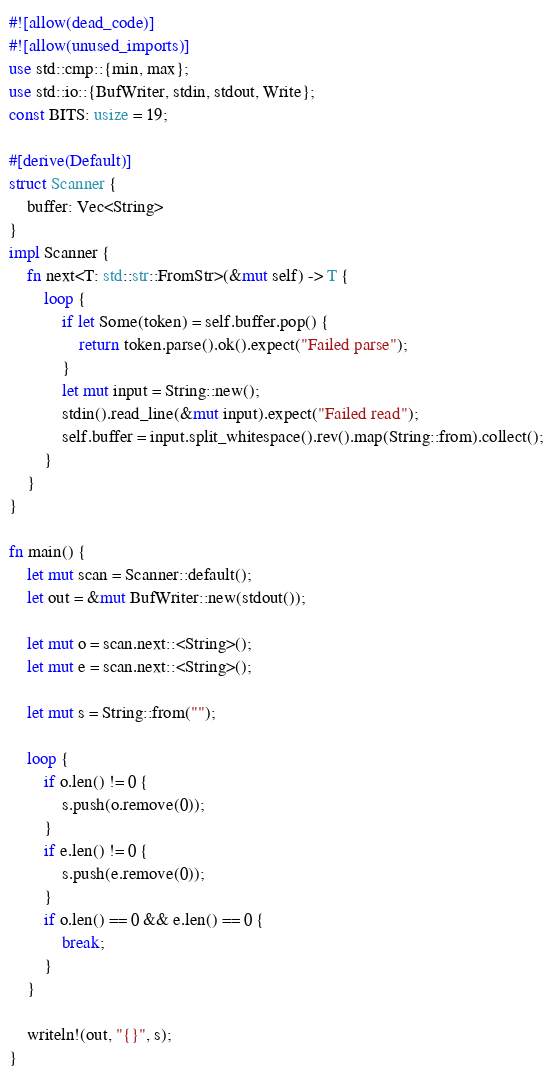<code> <loc_0><loc_0><loc_500><loc_500><_Rust_>#![allow(dead_code)]
#![allow(unused_imports)]
use std::cmp::{min, max};
use std::io::{BufWriter, stdin, stdout, Write};
const BITS: usize = 19;

#[derive(Default)]
struct Scanner {
    buffer: Vec<String>
}
impl Scanner {
    fn next<T: std::str::FromStr>(&mut self) -> T {
        loop {
            if let Some(token) = self.buffer.pop() {
                return token.parse().ok().expect("Failed parse");
            }
            let mut input = String::new();
            stdin().read_line(&mut input).expect("Failed read");
            self.buffer = input.split_whitespace().rev().map(String::from).collect();
        }
    }
}

fn main() {
    let mut scan = Scanner::default();
    let out = &mut BufWriter::new(stdout());

    let mut o = scan.next::<String>();
    let mut e = scan.next::<String>();

    let mut s = String::from("");

    loop {
        if o.len() != 0 {
            s.push(o.remove(0));
        }
        if e.len() != 0 {
            s.push(e.remove(0));
        }
        if o.len() == 0 && e.len() == 0 {
            break;
        }
    }

    writeln!(out, "{}", s);
}</code> 